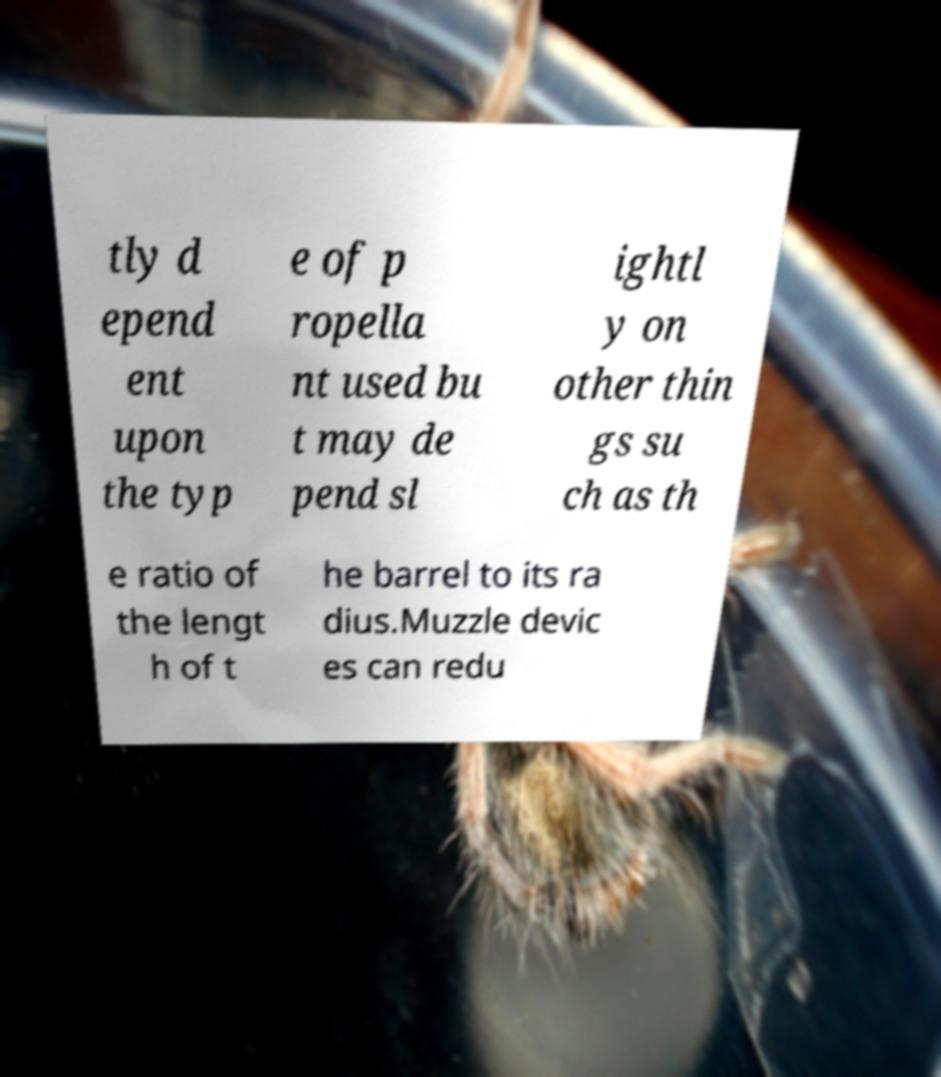Can you read and provide the text displayed in the image?This photo seems to have some interesting text. Can you extract and type it out for me? tly d epend ent upon the typ e of p ropella nt used bu t may de pend sl ightl y on other thin gs su ch as th e ratio of the lengt h of t he barrel to its ra dius.Muzzle devic es can redu 